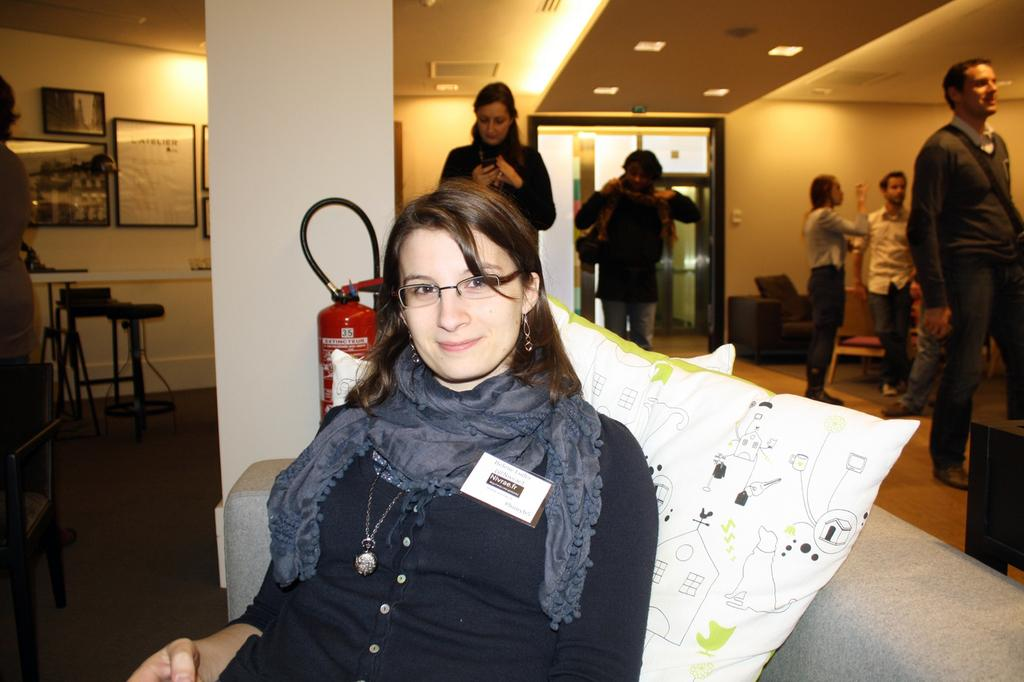What is the person in the image doing? The person is sitting on a sofa. What is the person wearing? The person is wearing a black dress. What can be seen behind the person sitting on the sofa? There are cushions behind the person. Are there any other people in the image? Yes, there are other people standing at the back. What can be seen in the background of the image? There are photo frames and pillars in the background. What type of box is the person playing in the image? There is no box present in the image, and the person is not playing any musical instruments. 